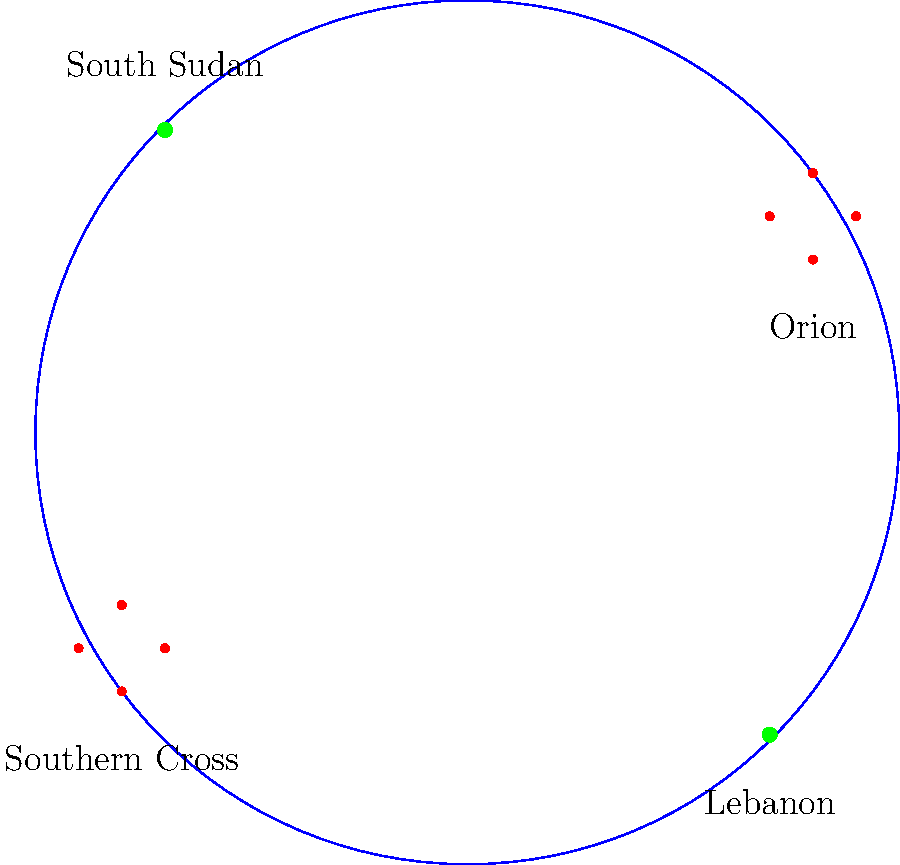As a UN peacekeeper, you're deployed to missions in Lebanon and South Sudan. Which of these constellations would you be more likely to see clearly during your nighttime patrols in South Sudan? To answer this question, we need to consider the following steps:

1. Understand the geographical locations:
   - Lebanon is in the Northern Hemisphere
   - South Sudan is near the equator, slightly in the Northern Hemisphere

2. Recall the visibility of constellations:
   - Orion is visible from both hemispheres but more prominent in the Northern sky
   - The Southern Cross is primarily visible from the Southern Hemisphere

3. Analyze the diagram:
   - Orion is shown in the Northern part of the sky
   - The Southern Cross is shown in the Southern part of the sky

4. Consider the mission location:
   - South Sudan is closer to the equator than Lebanon
   - Being near the equator allows for better visibility of both Northern and Southern constellations

5. Make the final determination:
   - While Orion might be visible from both locations, the Southern Cross would be much more clearly visible from South Sudan due to its proximity to the equator and the Southern Hemisphere

Therefore, during nighttime patrols in South Sudan, you would be more likely to see the Southern Cross clearly compared to your missions in Lebanon.
Answer: Southern Cross 